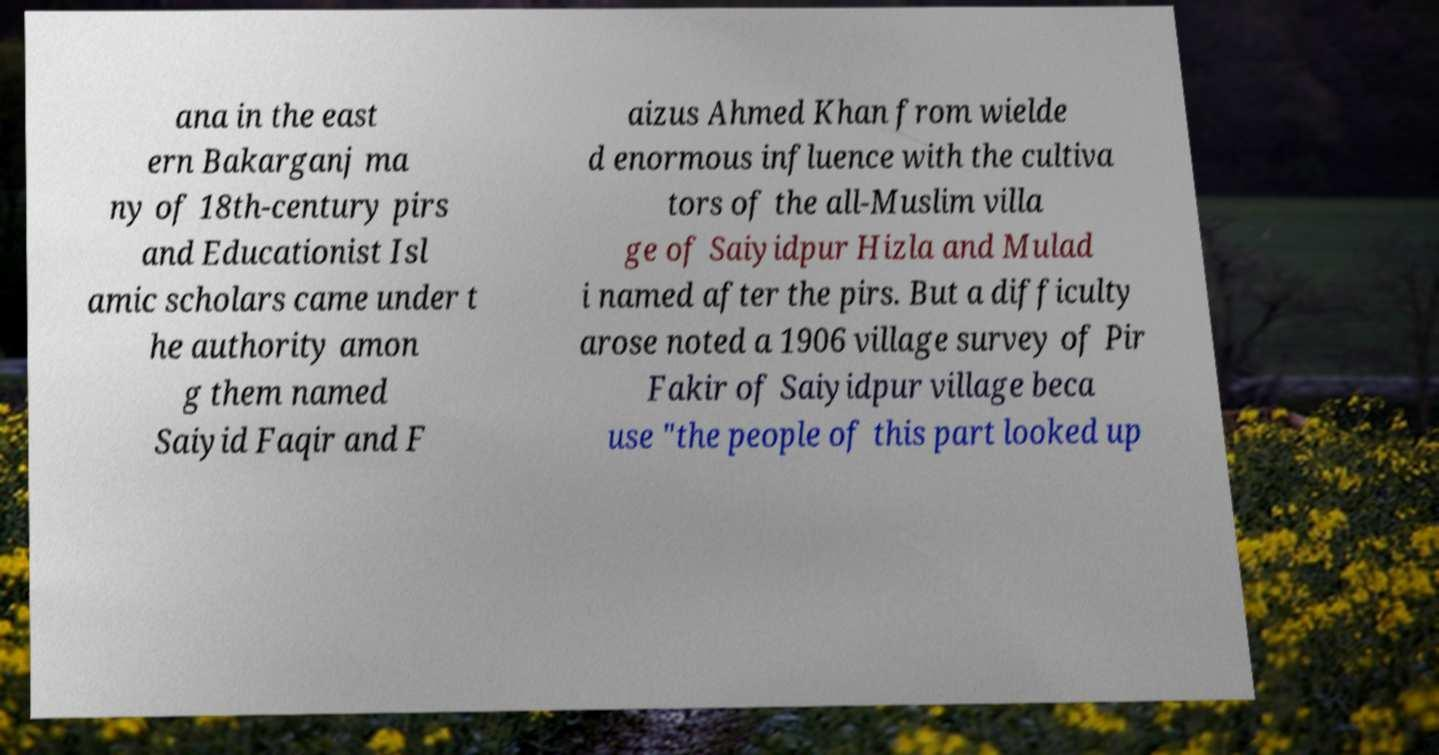Can you accurately transcribe the text from the provided image for me? ana in the east ern Bakarganj ma ny of 18th-century pirs and Educationist Isl amic scholars came under t he authority amon g them named Saiyid Faqir and F aizus Ahmed Khan from wielde d enormous influence with the cultiva tors of the all-Muslim villa ge of Saiyidpur Hizla and Mulad i named after the pirs. But a difficulty arose noted a 1906 village survey of Pir Fakir of Saiyidpur village beca use "the people of this part looked up 